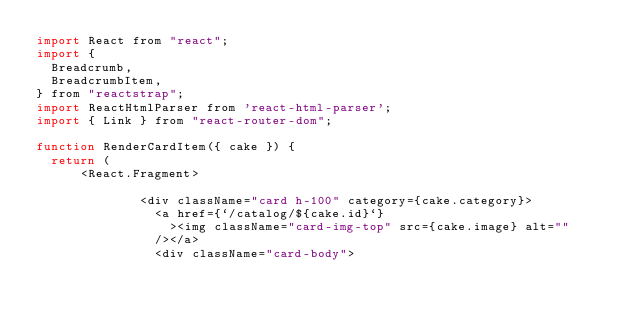Convert code to text. <code><loc_0><loc_0><loc_500><loc_500><_JavaScript_>import React from "react";
import {
  Breadcrumb,
  BreadcrumbItem,
} from "reactstrap";
import ReactHtmlParser from 'react-html-parser';
import { Link } from "react-router-dom";

function RenderCardItem({ cake }) {
  return (
      <React.Fragment>
            
              <div className="card h-100" category={cake.category}>
                <a href={`/catalog/${cake.id}`}
                  ><img className="card-img-top" src={cake.image} alt=""
                /></a>
                <div className="card-body"></code> 